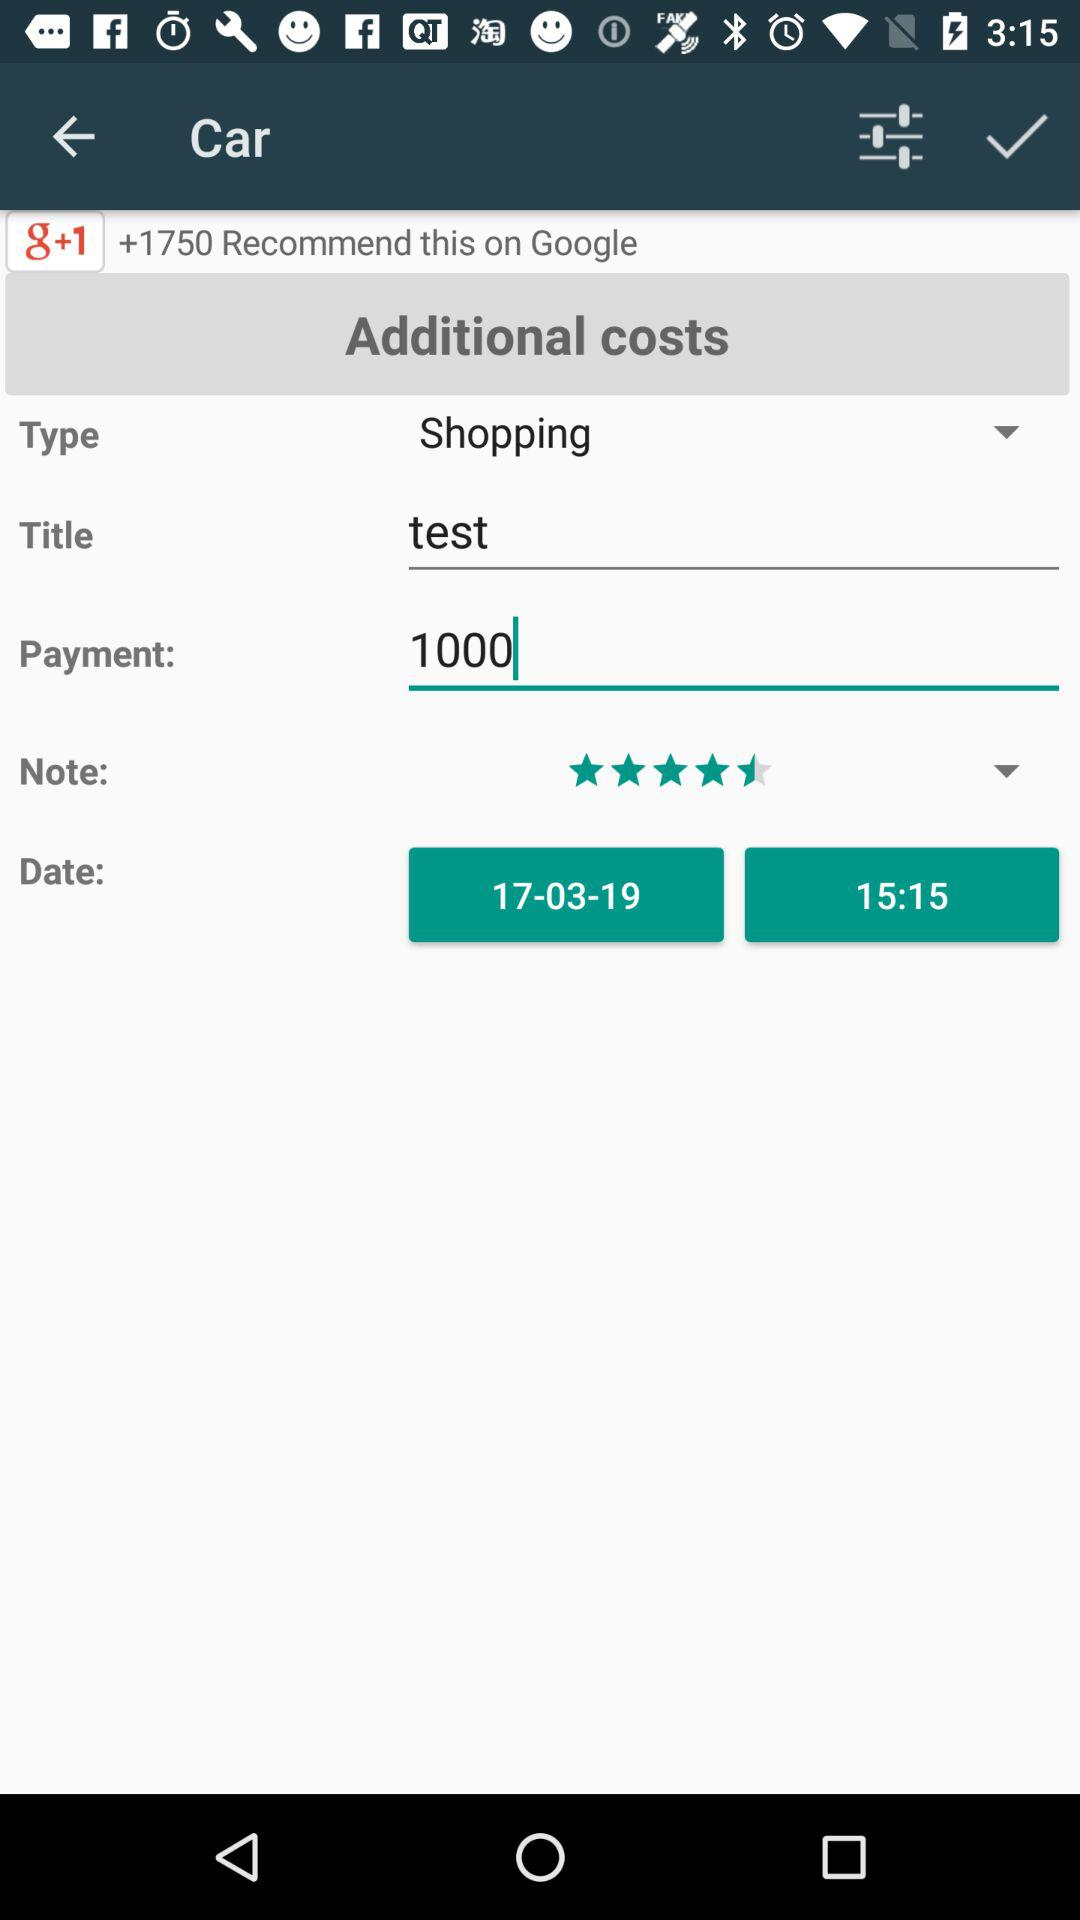What is the date? The date is March 17, 2019. 